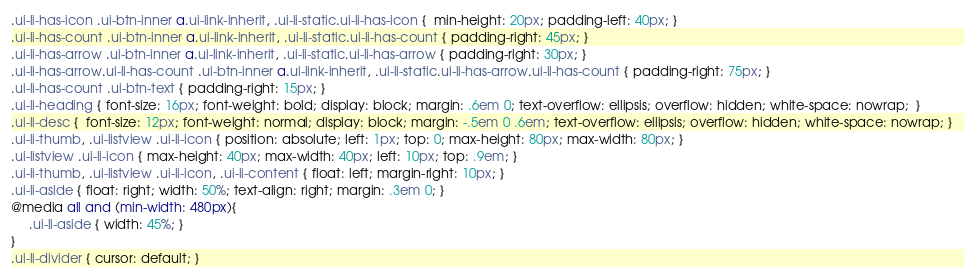<code> <loc_0><loc_0><loc_500><loc_500><_CSS_>.ui-li-has-icon .ui-btn-inner a.ui-link-inherit, .ui-li-static.ui-li-has-icon {  min-height: 20px; padding-left: 40px; }
.ui-li-has-count .ui-btn-inner a.ui-link-inherit, .ui-li-static.ui-li-has-count { padding-right: 45px; }
.ui-li-has-arrow .ui-btn-inner a.ui-link-inherit, .ui-li-static.ui-li-has-arrow { padding-right: 30px; }
.ui-li-has-arrow.ui-li-has-count .ui-btn-inner a.ui-link-inherit, .ui-li-static.ui-li-has-arrow.ui-li-has-count { padding-right: 75px; }
.ui-li-has-count .ui-btn-text { padding-right: 15px; }
.ui-li-heading { font-size: 16px; font-weight: bold; display: block; margin: .6em 0; text-overflow: ellipsis; overflow: hidden; white-space: nowrap;  }
.ui-li-desc {  font-size: 12px; font-weight: normal; display: block; margin: -.5em 0 .6em; text-overflow: ellipsis; overflow: hidden; white-space: nowrap; }
.ui-li-thumb, .ui-listview .ui-li-icon { position: absolute; left: 1px; top: 0; max-height: 80px; max-width: 80px; }
.ui-listview .ui-li-icon { max-height: 40px; max-width: 40px; left: 10px; top: .9em; }
.ui-li-thumb, .ui-listview .ui-li-icon, .ui-li-content { float: left; margin-right: 10px; }
.ui-li-aside { float: right; width: 50%; text-align: right; margin: .3em 0; }
@media all and (min-width: 480px){
	 .ui-li-aside { width: 45%; }
}	 
.ui-li-divider { cursor: default; }</code> 